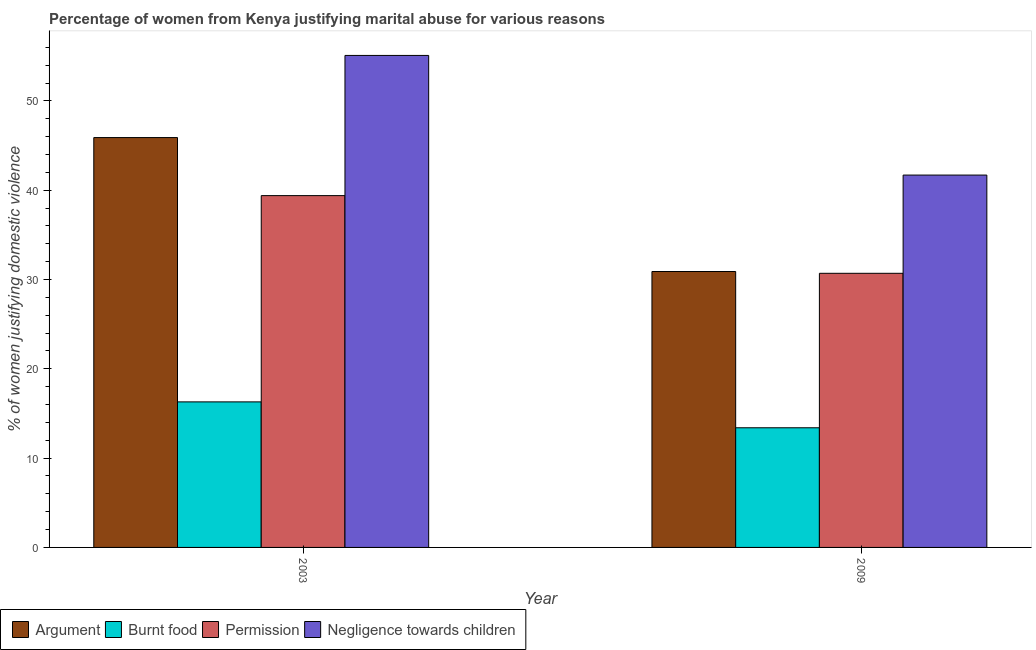How many groups of bars are there?
Offer a terse response. 2. Are the number of bars on each tick of the X-axis equal?
Your answer should be compact. Yes. How many bars are there on the 2nd tick from the left?
Offer a very short reply. 4. What is the label of the 1st group of bars from the left?
Ensure brevity in your answer.  2003. In how many cases, is the number of bars for a given year not equal to the number of legend labels?
Give a very brief answer. 0. What is the percentage of women justifying abuse for showing negligence towards children in 2009?
Make the answer very short. 41.7. Across all years, what is the maximum percentage of women justifying abuse for showing negligence towards children?
Provide a short and direct response. 55.1. Across all years, what is the minimum percentage of women justifying abuse for going without permission?
Keep it short and to the point. 30.7. What is the total percentage of women justifying abuse for going without permission in the graph?
Provide a succinct answer. 70.1. What is the average percentage of women justifying abuse in the case of an argument per year?
Provide a short and direct response. 38.4. What is the ratio of the percentage of women justifying abuse in the case of an argument in 2003 to that in 2009?
Offer a very short reply. 1.49. Is the percentage of women justifying abuse in the case of an argument in 2003 less than that in 2009?
Offer a terse response. No. In how many years, is the percentage of women justifying abuse in the case of an argument greater than the average percentage of women justifying abuse in the case of an argument taken over all years?
Your answer should be very brief. 1. What does the 3rd bar from the left in 2003 represents?
Provide a succinct answer. Permission. What does the 3rd bar from the right in 2003 represents?
Your response must be concise. Burnt food. How many bars are there?
Provide a succinct answer. 8. Are all the bars in the graph horizontal?
Your response must be concise. No. What is the difference between two consecutive major ticks on the Y-axis?
Keep it short and to the point. 10. Are the values on the major ticks of Y-axis written in scientific E-notation?
Ensure brevity in your answer.  No. Does the graph contain grids?
Provide a short and direct response. No. Where does the legend appear in the graph?
Give a very brief answer. Bottom left. How many legend labels are there?
Provide a short and direct response. 4. What is the title of the graph?
Give a very brief answer. Percentage of women from Kenya justifying marital abuse for various reasons. Does "Tertiary schools" appear as one of the legend labels in the graph?
Keep it short and to the point. No. What is the label or title of the X-axis?
Offer a very short reply. Year. What is the label or title of the Y-axis?
Offer a terse response. % of women justifying domestic violence. What is the % of women justifying domestic violence of Argument in 2003?
Make the answer very short. 45.9. What is the % of women justifying domestic violence of Permission in 2003?
Offer a very short reply. 39.4. What is the % of women justifying domestic violence in Negligence towards children in 2003?
Your response must be concise. 55.1. What is the % of women justifying domestic violence of Argument in 2009?
Keep it short and to the point. 30.9. What is the % of women justifying domestic violence of Permission in 2009?
Your response must be concise. 30.7. What is the % of women justifying domestic violence in Negligence towards children in 2009?
Your response must be concise. 41.7. Across all years, what is the maximum % of women justifying domestic violence of Argument?
Provide a succinct answer. 45.9. Across all years, what is the maximum % of women justifying domestic violence in Burnt food?
Your answer should be very brief. 16.3. Across all years, what is the maximum % of women justifying domestic violence in Permission?
Your answer should be compact. 39.4. Across all years, what is the maximum % of women justifying domestic violence in Negligence towards children?
Ensure brevity in your answer.  55.1. Across all years, what is the minimum % of women justifying domestic violence in Argument?
Provide a short and direct response. 30.9. Across all years, what is the minimum % of women justifying domestic violence of Burnt food?
Provide a succinct answer. 13.4. Across all years, what is the minimum % of women justifying domestic violence of Permission?
Give a very brief answer. 30.7. Across all years, what is the minimum % of women justifying domestic violence of Negligence towards children?
Provide a short and direct response. 41.7. What is the total % of women justifying domestic violence in Argument in the graph?
Give a very brief answer. 76.8. What is the total % of women justifying domestic violence in Burnt food in the graph?
Provide a succinct answer. 29.7. What is the total % of women justifying domestic violence in Permission in the graph?
Your response must be concise. 70.1. What is the total % of women justifying domestic violence of Negligence towards children in the graph?
Provide a short and direct response. 96.8. What is the difference between the % of women justifying domestic violence in Burnt food in 2003 and that in 2009?
Your answer should be compact. 2.9. What is the difference between the % of women justifying domestic violence in Permission in 2003 and that in 2009?
Provide a succinct answer. 8.7. What is the difference between the % of women justifying domestic violence of Negligence towards children in 2003 and that in 2009?
Keep it short and to the point. 13.4. What is the difference between the % of women justifying domestic violence of Argument in 2003 and the % of women justifying domestic violence of Burnt food in 2009?
Offer a terse response. 32.5. What is the difference between the % of women justifying domestic violence of Argument in 2003 and the % of women justifying domestic violence of Permission in 2009?
Keep it short and to the point. 15.2. What is the difference between the % of women justifying domestic violence in Burnt food in 2003 and the % of women justifying domestic violence in Permission in 2009?
Your answer should be compact. -14.4. What is the difference between the % of women justifying domestic violence in Burnt food in 2003 and the % of women justifying domestic violence in Negligence towards children in 2009?
Ensure brevity in your answer.  -25.4. What is the average % of women justifying domestic violence in Argument per year?
Your answer should be very brief. 38.4. What is the average % of women justifying domestic violence in Burnt food per year?
Keep it short and to the point. 14.85. What is the average % of women justifying domestic violence of Permission per year?
Keep it short and to the point. 35.05. What is the average % of women justifying domestic violence in Negligence towards children per year?
Provide a succinct answer. 48.4. In the year 2003, what is the difference between the % of women justifying domestic violence in Argument and % of women justifying domestic violence in Burnt food?
Your response must be concise. 29.6. In the year 2003, what is the difference between the % of women justifying domestic violence in Argument and % of women justifying domestic violence in Permission?
Your response must be concise. 6.5. In the year 2003, what is the difference between the % of women justifying domestic violence in Argument and % of women justifying domestic violence in Negligence towards children?
Ensure brevity in your answer.  -9.2. In the year 2003, what is the difference between the % of women justifying domestic violence in Burnt food and % of women justifying domestic violence in Permission?
Provide a short and direct response. -23.1. In the year 2003, what is the difference between the % of women justifying domestic violence of Burnt food and % of women justifying domestic violence of Negligence towards children?
Provide a short and direct response. -38.8. In the year 2003, what is the difference between the % of women justifying domestic violence in Permission and % of women justifying domestic violence in Negligence towards children?
Your answer should be very brief. -15.7. In the year 2009, what is the difference between the % of women justifying domestic violence in Argument and % of women justifying domestic violence in Negligence towards children?
Offer a terse response. -10.8. In the year 2009, what is the difference between the % of women justifying domestic violence in Burnt food and % of women justifying domestic violence in Permission?
Keep it short and to the point. -17.3. In the year 2009, what is the difference between the % of women justifying domestic violence in Burnt food and % of women justifying domestic violence in Negligence towards children?
Your answer should be very brief. -28.3. What is the ratio of the % of women justifying domestic violence of Argument in 2003 to that in 2009?
Offer a very short reply. 1.49. What is the ratio of the % of women justifying domestic violence of Burnt food in 2003 to that in 2009?
Offer a very short reply. 1.22. What is the ratio of the % of women justifying domestic violence of Permission in 2003 to that in 2009?
Make the answer very short. 1.28. What is the ratio of the % of women justifying domestic violence of Negligence towards children in 2003 to that in 2009?
Make the answer very short. 1.32. What is the difference between the highest and the second highest % of women justifying domestic violence of Argument?
Your answer should be compact. 15. What is the difference between the highest and the second highest % of women justifying domestic violence of Burnt food?
Give a very brief answer. 2.9. What is the difference between the highest and the second highest % of women justifying domestic violence of Negligence towards children?
Offer a very short reply. 13.4. What is the difference between the highest and the lowest % of women justifying domestic violence in Argument?
Your answer should be compact. 15. What is the difference between the highest and the lowest % of women justifying domestic violence of Burnt food?
Offer a very short reply. 2.9. What is the difference between the highest and the lowest % of women justifying domestic violence in Permission?
Provide a short and direct response. 8.7. What is the difference between the highest and the lowest % of women justifying domestic violence in Negligence towards children?
Provide a succinct answer. 13.4. 